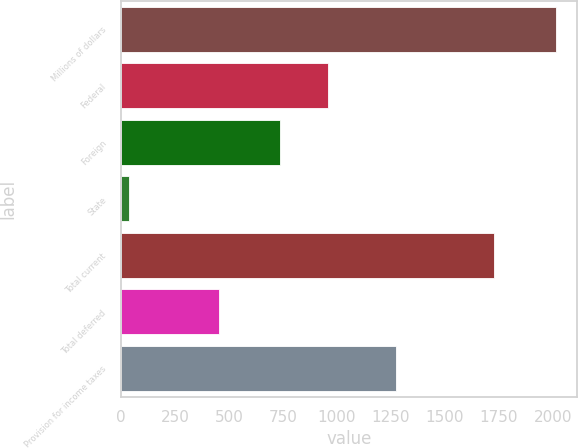<chart> <loc_0><loc_0><loc_500><loc_500><bar_chart><fcel>Millions of dollars<fcel>Federal<fcel>Foreign<fcel>State<fcel>Total current<fcel>Total deferred<fcel>Provision for income taxes<nl><fcel>2014<fcel>959<fcel>734<fcel>36<fcel>1729<fcel>454<fcel>1275<nl></chart> 